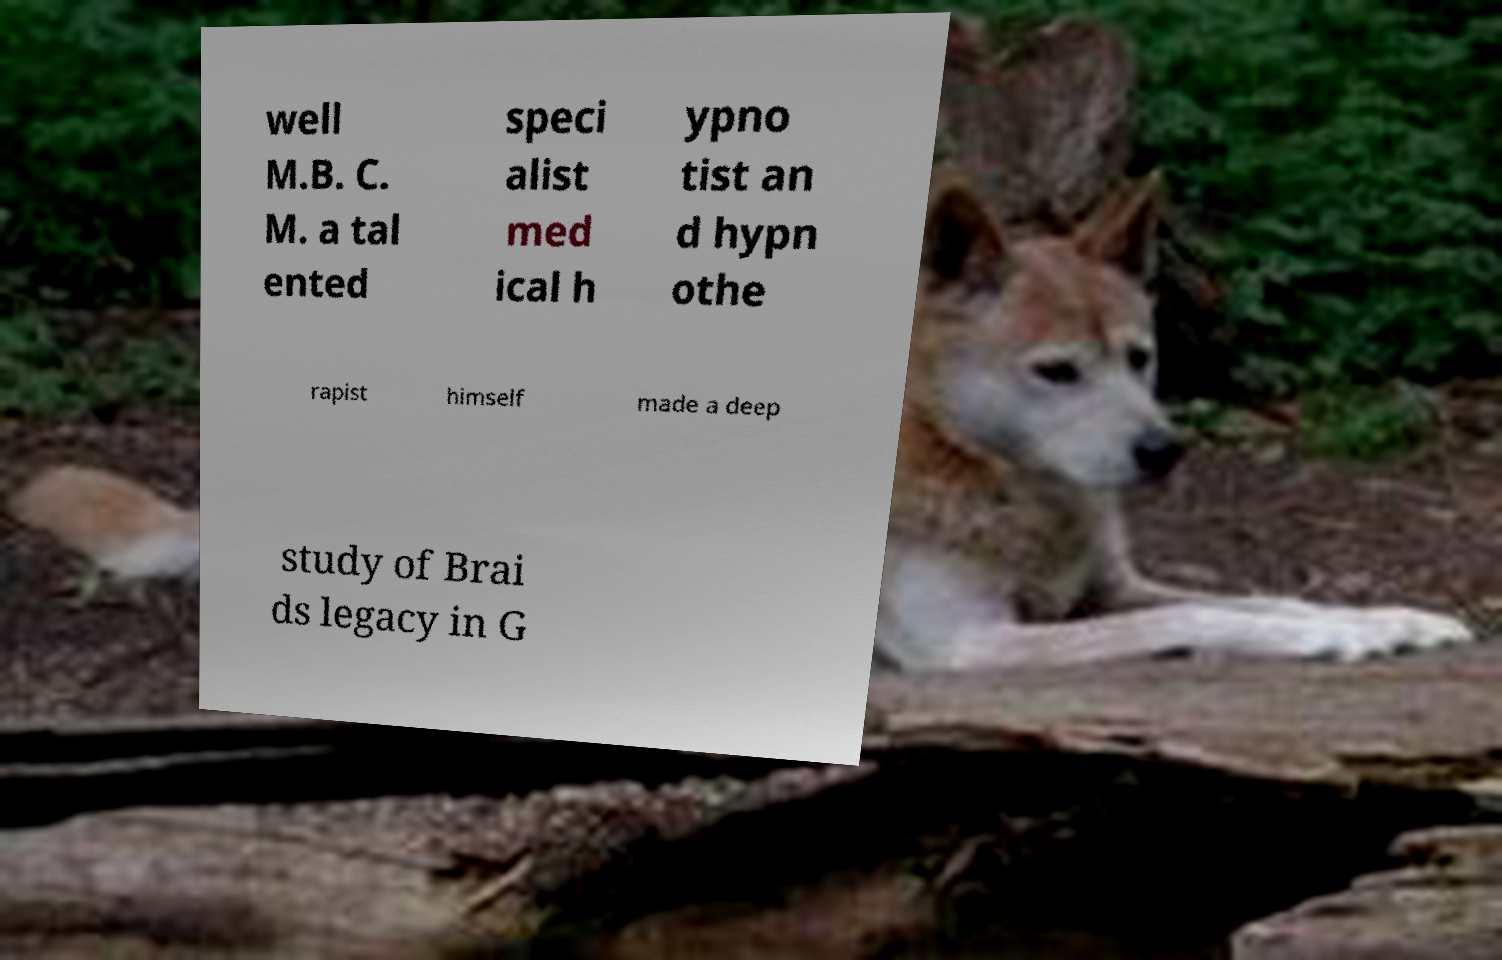Can you accurately transcribe the text from the provided image for me? well M.B. C. M. a tal ented speci alist med ical h ypno tist an d hypn othe rapist himself made a deep study of Brai ds legacy in G 